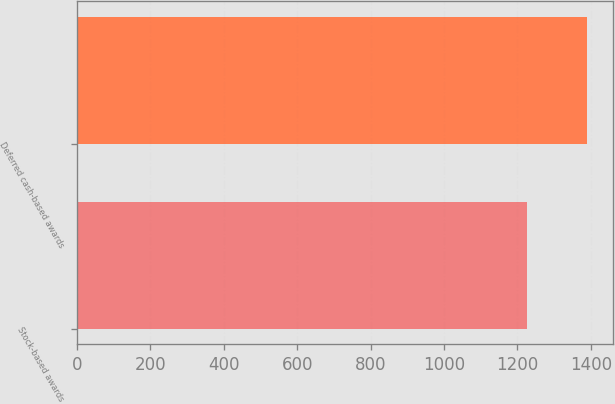<chart> <loc_0><loc_0><loc_500><loc_500><bar_chart><fcel>Stock-based awards<fcel>Deferred cash-based awards<nl><fcel>1227<fcel>1391<nl></chart> 